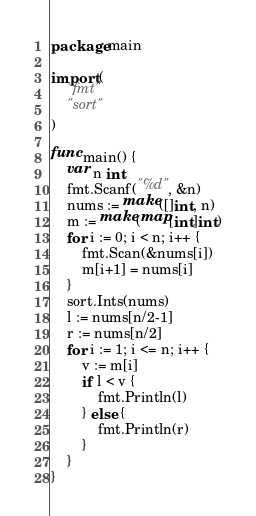Convert code to text. <code><loc_0><loc_0><loc_500><loc_500><_Go_>package main

import (
	"fmt"
	"sort"
)

func main() {
	var n int
	fmt.Scanf("%d", &n)
	nums := make([]int, n)
	m := make(map[int]int)
	for i := 0; i < n; i++ {
		fmt.Scan(&nums[i])
		m[i+1] = nums[i]
	}
	sort.Ints(nums)
	l := nums[n/2-1]
	r := nums[n/2]
	for i := 1; i <= n; i++ {
		v := m[i]
		if l < v {
			fmt.Println(l)
		} else {
			fmt.Println(r)
		}
	}
}
</code> 